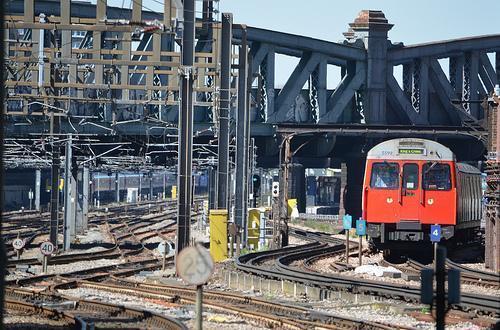How many trains are there?
Give a very brief answer. 1. 